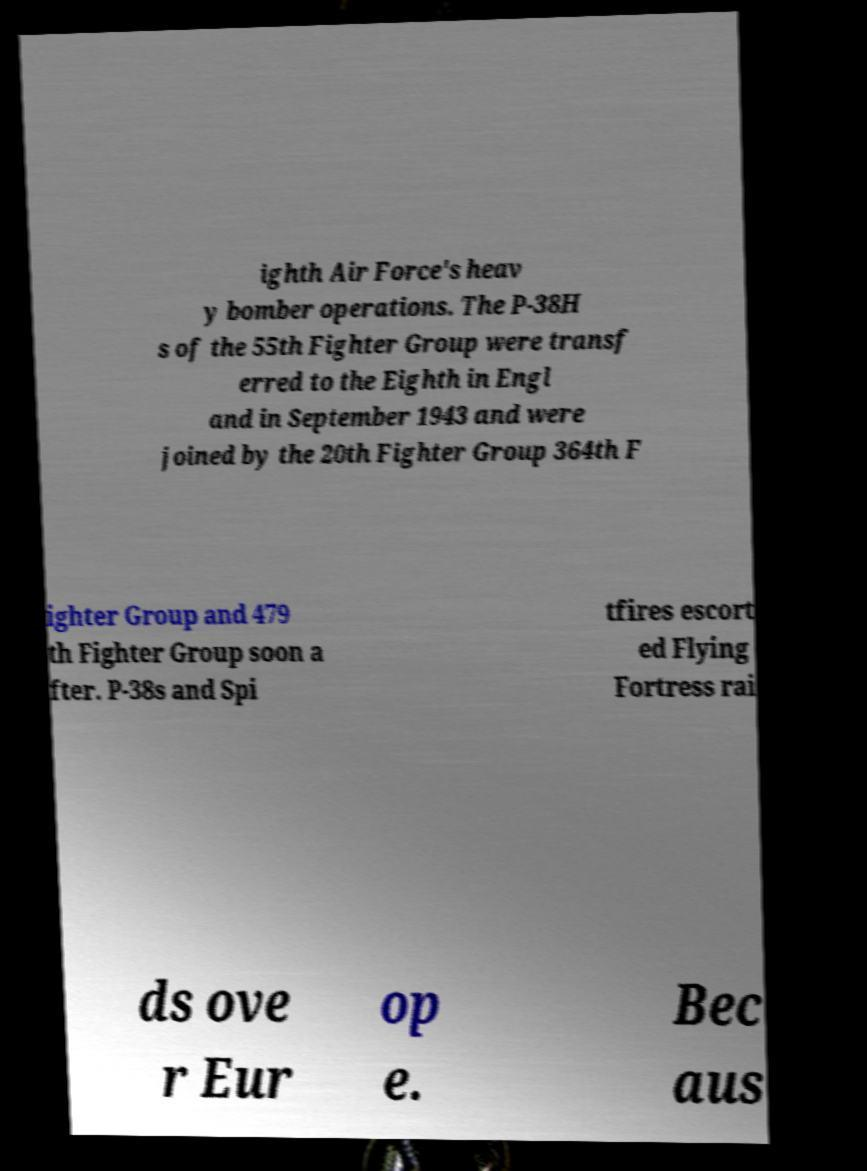What messages or text are displayed in this image? I need them in a readable, typed format. ighth Air Force's heav y bomber operations. The P-38H s of the 55th Fighter Group were transf erred to the Eighth in Engl and in September 1943 and were joined by the 20th Fighter Group 364th F ighter Group and 479 th Fighter Group soon a fter. P-38s and Spi tfires escort ed Flying Fortress rai ds ove r Eur op e. Bec aus 